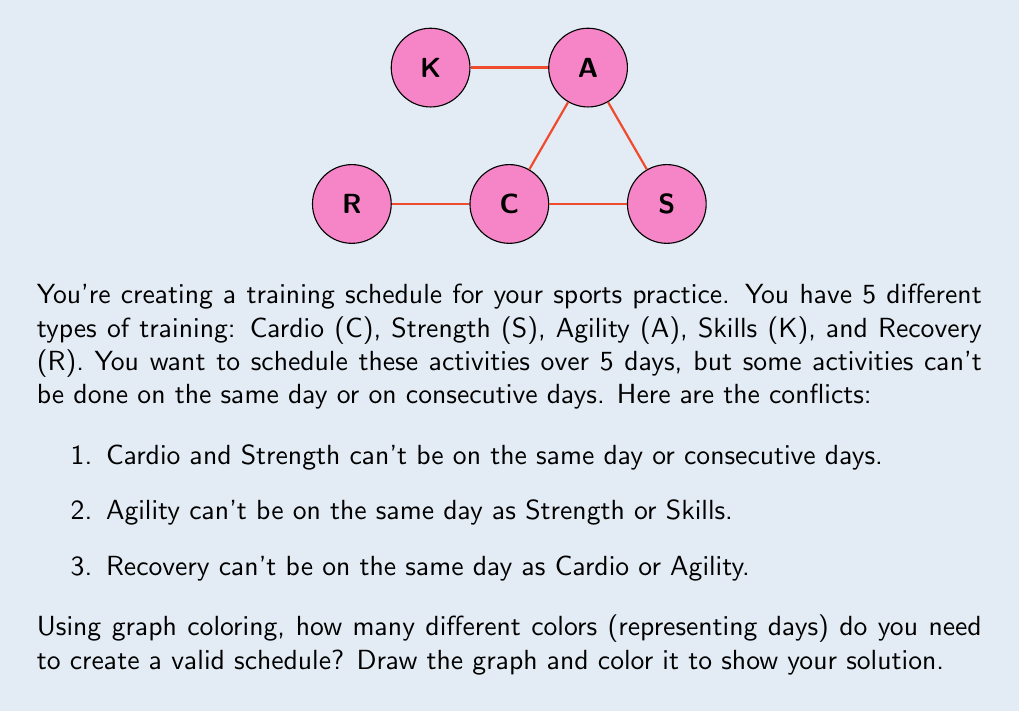Teach me how to tackle this problem. Let's approach this step-by-step:

1) First, we need to create a graph where each vertex represents a training activity, and edges connect activities that can't be scheduled on the same day or consecutive days.

2) From the given conflicts, we can draw the following edges:
   - C -- S (Cardio and Strength)
   - C -- R (Cardio and Recovery)
   - S -- A (Strength and Agility)
   - A -- K (Agility and Skills)
   - A -- R (Agility and Recovery)

3) Now, we need to color this graph such that no two adjacent vertices have the same color. Each color represents a different day.

4) Let's start coloring:
   - Assign color 1 to C
   - S can't have color 1, so assign color 2 to S
   - A can't have color 2, so assign color 3 to A
   - K can have color 1 or 2, let's choose color 1
   - R can't have color 1 or 3, so assign color 2 to R

5) We've successfully colored the graph using 3 colors, which means we need 3 different days to schedule all activities without conflicts.

6) A possible schedule could be:
   Day 1 (Color 1): Cardio and Skills
   Day 2 (Color 2): Strength and Recovery
   Day 3 (Color 3): Agility

This coloring satisfies all the constraints given in the problem.
Answer: 3 colors (days) 